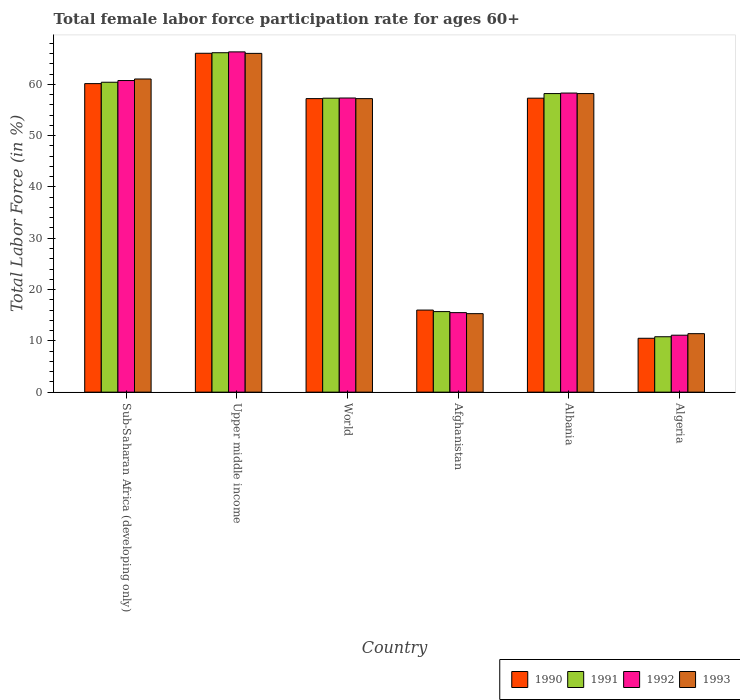How many groups of bars are there?
Provide a short and direct response. 6. What is the label of the 4th group of bars from the left?
Give a very brief answer. Afghanistan. What is the female labor force participation rate in 1991 in Afghanistan?
Keep it short and to the point. 15.7. Across all countries, what is the maximum female labor force participation rate in 1992?
Ensure brevity in your answer.  66.32. Across all countries, what is the minimum female labor force participation rate in 1991?
Offer a very short reply. 10.8. In which country was the female labor force participation rate in 1993 maximum?
Keep it short and to the point. Upper middle income. In which country was the female labor force participation rate in 1993 minimum?
Keep it short and to the point. Algeria. What is the total female labor force participation rate in 1992 in the graph?
Offer a very short reply. 269.3. What is the difference between the female labor force participation rate in 1990 in Algeria and that in World?
Provide a succinct answer. -46.71. What is the difference between the female labor force participation rate in 1991 in World and the female labor force participation rate in 1992 in Albania?
Provide a short and direct response. -1. What is the average female labor force participation rate in 1993 per country?
Your answer should be compact. 44.86. What is the difference between the female labor force participation rate of/in 1993 and female labor force participation rate of/in 1992 in Upper middle income?
Your answer should be very brief. -0.29. What is the ratio of the female labor force participation rate in 1990 in Albania to that in Upper middle income?
Offer a terse response. 0.87. What is the difference between the highest and the second highest female labor force participation rate in 1990?
Offer a terse response. -8.75. What is the difference between the highest and the lowest female labor force participation rate in 1993?
Provide a succinct answer. 54.63. Is the sum of the female labor force participation rate in 1991 in Albania and Algeria greater than the maximum female labor force participation rate in 1990 across all countries?
Offer a terse response. Yes. Is it the case that in every country, the sum of the female labor force participation rate in 1990 and female labor force participation rate in 1993 is greater than the sum of female labor force participation rate in 1992 and female labor force participation rate in 1991?
Offer a terse response. No. What does the 1st bar from the left in Sub-Saharan Africa (developing only) represents?
Your answer should be very brief. 1990. What does the 3rd bar from the right in World represents?
Your answer should be compact. 1991. Is it the case that in every country, the sum of the female labor force participation rate in 1993 and female labor force participation rate in 1991 is greater than the female labor force participation rate in 1990?
Your answer should be compact. Yes. Are all the bars in the graph horizontal?
Your answer should be very brief. No. How many countries are there in the graph?
Offer a very short reply. 6. What is the difference between two consecutive major ticks on the Y-axis?
Offer a terse response. 10. Are the values on the major ticks of Y-axis written in scientific E-notation?
Your answer should be very brief. No. Does the graph contain any zero values?
Make the answer very short. No. How many legend labels are there?
Ensure brevity in your answer.  4. What is the title of the graph?
Offer a terse response. Total female labor force participation rate for ages 60+. Does "2010" appear as one of the legend labels in the graph?
Your response must be concise. No. What is the label or title of the Y-axis?
Your answer should be very brief. Total Labor Force (in %). What is the Total Labor Force (in %) in 1990 in Sub-Saharan Africa (developing only)?
Offer a very short reply. 60.14. What is the Total Labor Force (in %) of 1991 in Sub-Saharan Africa (developing only)?
Provide a succinct answer. 60.41. What is the Total Labor Force (in %) in 1992 in Sub-Saharan Africa (developing only)?
Provide a succinct answer. 60.74. What is the Total Labor Force (in %) of 1993 in Sub-Saharan Africa (developing only)?
Ensure brevity in your answer.  61.04. What is the Total Labor Force (in %) of 1990 in Upper middle income?
Give a very brief answer. 66.05. What is the Total Labor Force (in %) of 1991 in Upper middle income?
Give a very brief answer. 66.16. What is the Total Labor Force (in %) of 1992 in Upper middle income?
Provide a short and direct response. 66.32. What is the Total Labor Force (in %) of 1993 in Upper middle income?
Ensure brevity in your answer.  66.03. What is the Total Labor Force (in %) in 1990 in World?
Keep it short and to the point. 57.21. What is the Total Labor Force (in %) of 1991 in World?
Offer a terse response. 57.3. What is the Total Labor Force (in %) in 1992 in World?
Keep it short and to the point. 57.33. What is the Total Labor Force (in %) in 1993 in World?
Your answer should be very brief. 57.21. What is the Total Labor Force (in %) in 1991 in Afghanistan?
Your response must be concise. 15.7. What is the Total Labor Force (in %) of 1993 in Afghanistan?
Offer a terse response. 15.3. What is the Total Labor Force (in %) in 1990 in Albania?
Give a very brief answer. 57.3. What is the Total Labor Force (in %) in 1991 in Albania?
Offer a terse response. 58.2. What is the Total Labor Force (in %) in 1992 in Albania?
Provide a short and direct response. 58.3. What is the Total Labor Force (in %) of 1993 in Albania?
Your answer should be compact. 58.2. What is the Total Labor Force (in %) in 1991 in Algeria?
Your answer should be compact. 10.8. What is the Total Labor Force (in %) in 1992 in Algeria?
Your answer should be very brief. 11.1. What is the Total Labor Force (in %) in 1993 in Algeria?
Offer a terse response. 11.4. Across all countries, what is the maximum Total Labor Force (in %) of 1990?
Your response must be concise. 66.05. Across all countries, what is the maximum Total Labor Force (in %) in 1991?
Offer a very short reply. 66.16. Across all countries, what is the maximum Total Labor Force (in %) of 1992?
Keep it short and to the point. 66.32. Across all countries, what is the maximum Total Labor Force (in %) of 1993?
Offer a very short reply. 66.03. Across all countries, what is the minimum Total Labor Force (in %) in 1990?
Offer a terse response. 10.5. Across all countries, what is the minimum Total Labor Force (in %) in 1991?
Provide a short and direct response. 10.8. Across all countries, what is the minimum Total Labor Force (in %) in 1992?
Provide a succinct answer. 11.1. Across all countries, what is the minimum Total Labor Force (in %) of 1993?
Keep it short and to the point. 11.4. What is the total Total Labor Force (in %) in 1990 in the graph?
Your answer should be very brief. 267.21. What is the total Total Labor Force (in %) of 1991 in the graph?
Make the answer very short. 268.57. What is the total Total Labor Force (in %) in 1992 in the graph?
Offer a very short reply. 269.3. What is the total Total Labor Force (in %) of 1993 in the graph?
Your answer should be compact. 269.18. What is the difference between the Total Labor Force (in %) of 1990 in Sub-Saharan Africa (developing only) and that in Upper middle income?
Keep it short and to the point. -5.92. What is the difference between the Total Labor Force (in %) in 1991 in Sub-Saharan Africa (developing only) and that in Upper middle income?
Keep it short and to the point. -5.75. What is the difference between the Total Labor Force (in %) in 1992 in Sub-Saharan Africa (developing only) and that in Upper middle income?
Your response must be concise. -5.58. What is the difference between the Total Labor Force (in %) of 1993 in Sub-Saharan Africa (developing only) and that in Upper middle income?
Give a very brief answer. -4.99. What is the difference between the Total Labor Force (in %) of 1990 in Sub-Saharan Africa (developing only) and that in World?
Your answer should be compact. 2.92. What is the difference between the Total Labor Force (in %) in 1991 in Sub-Saharan Africa (developing only) and that in World?
Your response must be concise. 3.11. What is the difference between the Total Labor Force (in %) of 1992 in Sub-Saharan Africa (developing only) and that in World?
Keep it short and to the point. 3.41. What is the difference between the Total Labor Force (in %) in 1993 in Sub-Saharan Africa (developing only) and that in World?
Make the answer very short. 3.83. What is the difference between the Total Labor Force (in %) in 1990 in Sub-Saharan Africa (developing only) and that in Afghanistan?
Ensure brevity in your answer.  44.14. What is the difference between the Total Labor Force (in %) in 1991 in Sub-Saharan Africa (developing only) and that in Afghanistan?
Provide a succinct answer. 44.71. What is the difference between the Total Labor Force (in %) of 1992 in Sub-Saharan Africa (developing only) and that in Afghanistan?
Give a very brief answer. 45.24. What is the difference between the Total Labor Force (in %) in 1993 in Sub-Saharan Africa (developing only) and that in Afghanistan?
Provide a succinct answer. 45.74. What is the difference between the Total Labor Force (in %) in 1990 in Sub-Saharan Africa (developing only) and that in Albania?
Your answer should be very brief. 2.84. What is the difference between the Total Labor Force (in %) in 1991 in Sub-Saharan Africa (developing only) and that in Albania?
Your answer should be very brief. 2.21. What is the difference between the Total Labor Force (in %) of 1992 in Sub-Saharan Africa (developing only) and that in Albania?
Your answer should be very brief. 2.44. What is the difference between the Total Labor Force (in %) in 1993 in Sub-Saharan Africa (developing only) and that in Albania?
Ensure brevity in your answer.  2.84. What is the difference between the Total Labor Force (in %) of 1990 in Sub-Saharan Africa (developing only) and that in Algeria?
Offer a terse response. 49.64. What is the difference between the Total Labor Force (in %) of 1991 in Sub-Saharan Africa (developing only) and that in Algeria?
Your answer should be compact. 49.61. What is the difference between the Total Labor Force (in %) of 1992 in Sub-Saharan Africa (developing only) and that in Algeria?
Keep it short and to the point. 49.64. What is the difference between the Total Labor Force (in %) in 1993 in Sub-Saharan Africa (developing only) and that in Algeria?
Make the answer very short. 49.64. What is the difference between the Total Labor Force (in %) in 1990 in Upper middle income and that in World?
Keep it short and to the point. 8.84. What is the difference between the Total Labor Force (in %) in 1991 in Upper middle income and that in World?
Ensure brevity in your answer.  8.86. What is the difference between the Total Labor Force (in %) in 1992 in Upper middle income and that in World?
Make the answer very short. 8.99. What is the difference between the Total Labor Force (in %) of 1993 in Upper middle income and that in World?
Your answer should be compact. 8.82. What is the difference between the Total Labor Force (in %) in 1990 in Upper middle income and that in Afghanistan?
Ensure brevity in your answer.  50.05. What is the difference between the Total Labor Force (in %) of 1991 in Upper middle income and that in Afghanistan?
Give a very brief answer. 50.46. What is the difference between the Total Labor Force (in %) of 1992 in Upper middle income and that in Afghanistan?
Ensure brevity in your answer.  50.82. What is the difference between the Total Labor Force (in %) in 1993 in Upper middle income and that in Afghanistan?
Offer a very short reply. 50.73. What is the difference between the Total Labor Force (in %) in 1990 in Upper middle income and that in Albania?
Make the answer very short. 8.75. What is the difference between the Total Labor Force (in %) of 1991 in Upper middle income and that in Albania?
Your answer should be compact. 7.96. What is the difference between the Total Labor Force (in %) in 1992 in Upper middle income and that in Albania?
Give a very brief answer. 8.02. What is the difference between the Total Labor Force (in %) of 1993 in Upper middle income and that in Albania?
Keep it short and to the point. 7.83. What is the difference between the Total Labor Force (in %) in 1990 in Upper middle income and that in Algeria?
Provide a succinct answer. 55.55. What is the difference between the Total Labor Force (in %) of 1991 in Upper middle income and that in Algeria?
Provide a short and direct response. 55.36. What is the difference between the Total Labor Force (in %) in 1992 in Upper middle income and that in Algeria?
Keep it short and to the point. 55.22. What is the difference between the Total Labor Force (in %) of 1993 in Upper middle income and that in Algeria?
Give a very brief answer. 54.63. What is the difference between the Total Labor Force (in %) in 1990 in World and that in Afghanistan?
Offer a terse response. 41.21. What is the difference between the Total Labor Force (in %) in 1991 in World and that in Afghanistan?
Provide a succinct answer. 41.6. What is the difference between the Total Labor Force (in %) in 1992 in World and that in Afghanistan?
Provide a short and direct response. 41.83. What is the difference between the Total Labor Force (in %) of 1993 in World and that in Afghanistan?
Your answer should be very brief. 41.91. What is the difference between the Total Labor Force (in %) of 1990 in World and that in Albania?
Give a very brief answer. -0.09. What is the difference between the Total Labor Force (in %) of 1991 in World and that in Albania?
Provide a succinct answer. -0.9. What is the difference between the Total Labor Force (in %) in 1992 in World and that in Albania?
Ensure brevity in your answer.  -0.97. What is the difference between the Total Labor Force (in %) of 1993 in World and that in Albania?
Your response must be concise. -0.99. What is the difference between the Total Labor Force (in %) of 1990 in World and that in Algeria?
Provide a short and direct response. 46.71. What is the difference between the Total Labor Force (in %) in 1991 in World and that in Algeria?
Provide a short and direct response. 46.5. What is the difference between the Total Labor Force (in %) of 1992 in World and that in Algeria?
Offer a very short reply. 46.23. What is the difference between the Total Labor Force (in %) of 1993 in World and that in Algeria?
Your response must be concise. 45.81. What is the difference between the Total Labor Force (in %) of 1990 in Afghanistan and that in Albania?
Offer a terse response. -41.3. What is the difference between the Total Labor Force (in %) in 1991 in Afghanistan and that in Albania?
Provide a succinct answer. -42.5. What is the difference between the Total Labor Force (in %) of 1992 in Afghanistan and that in Albania?
Give a very brief answer. -42.8. What is the difference between the Total Labor Force (in %) in 1993 in Afghanistan and that in Albania?
Offer a very short reply. -42.9. What is the difference between the Total Labor Force (in %) of 1990 in Afghanistan and that in Algeria?
Make the answer very short. 5.5. What is the difference between the Total Labor Force (in %) in 1991 in Afghanistan and that in Algeria?
Offer a terse response. 4.9. What is the difference between the Total Labor Force (in %) of 1990 in Albania and that in Algeria?
Offer a very short reply. 46.8. What is the difference between the Total Labor Force (in %) of 1991 in Albania and that in Algeria?
Make the answer very short. 47.4. What is the difference between the Total Labor Force (in %) of 1992 in Albania and that in Algeria?
Keep it short and to the point. 47.2. What is the difference between the Total Labor Force (in %) in 1993 in Albania and that in Algeria?
Make the answer very short. 46.8. What is the difference between the Total Labor Force (in %) of 1990 in Sub-Saharan Africa (developing only) and the Total Labor Force (in %) of 1991 in Upper middle income?
Your response must be concise. -6.02. What is the difference between the Total Labor Force (in %) in 1990 in Sub-Saharan Africa (developing only) and the Total Labor Force (in %) in 1992 in Upper middle income?
Your response must be concise. -6.18. What is the difference between the Total Labor Force (in %) in 1990 in Sub-Saharan Africa (developing only) and the Total Labor Force (in %) in 1993 in Upper middle income?
Offer a very short reply. -5.89. What is the difference between the Total Labor Force (in %) of 1991 in Sub-Saharan Africa (developing only) and the Total Labor Force (in %) of 1992 in Upper middle income?
Provide a succinct answer. -5.92. What is the difference between the Total Labor Force (in %) in 1991 in Sub-Saharan Africa (developing only) and the Total Labor Force (in %) in 1993 in Upper middle income?
Your answer should be very brief. -5.63. What is the difference between the Total Labor Force (in %) of 1992 in Sub-Saharan Africa (developing only) and the Total Labor Force (in %) of 1993 in Upper middle income?
Offer a very short reply. -5.29. What is the difference between the Total Labor Force (in %) of 1990 in Sub-Saharan Africa (developing only) and the Total Labor Force (in %) of 1991 in World?
Make the answer very short. 2.84. What is the difference between the Total Labor Force (in %) of 1990 in Sub-Saharan Africa (developing only) and the Total Labor Force (in %) of 1992 in World?
Ensure brevity in your answer.  2.81. What is the difference between the Total Labor Force (in %) in 1990 in Sub-Saharan Africa (developing only) and the Total Labor Force (in %) in 1993 in World?
Offer a very short reply. 2.93. What is the difference between the Total Labor Force (in %) of 1991 in Sub-Saharan Africa (developing only) and the Total Labor Force (in %) of 1992 in World?
Your response must be concise. 3.07. What is the difference between the Total Labor Force (in %) in 1991 in Sub-Saharan Africa (developing only) and the Total Labor Force (in %) in 1993 in World?
Provide a short and direct response. 3.2. What is the difference between the Total Labor Force (in %) of 1992 in Sub-Saharan Africa (developing only) and the Total Labor Force (in %) of 1993 in World?
Your response must be concise. 3.53. What is the difference between the Total Labor Force (in %) of 1990 in Sub-Saharan Africa (developing only) and the Total Labor Force (in %) of 1991 in Afghanistan?
Offer a very short reply. 44.44. What is the difference between the Total Labor Force (in %) in 1990 in Sub-Saharan Africa (developing only) and the Total Labor Force (in %) in 1992 in Afghanistan?
Ensure brevity in your answer.  44.64. What is the difference between the Total Labor Force (in %) of 1990 in Sub-Saharan Africa (developing only) and the Total Labor Force (in %) of 1993 in Afghanistan?
Provide a short and direct response. 44.84. What is the difference between the Total Labor Force (in %) of 1991 in Sub-Saharan Africa (developing only) and the Total Labor Force (in %) of 1992 in Afghanistan?
Offer a terse response. 44.91. What is the difference between the Total Labor Force (in %) of 1991 in Sub-Saharan Africa (developing only) and the Total Labor Force (in %) of 1993 in Afghanistan?
Ensure brevity in your answer.  45.11. What is the difference between the Total Labor Force (in %) in 1992 in Sub-Saharan Africa (developing only) and the Total Labor Force (in %) in 1993 in Afghanistan?
Ensure brevity in your answer.  45.44. What is the difference between the Total Labor Force (in %) in 1990 in Sub-Saharan Africa (developing only) and the Total Labor Force (in %) in 1991 in Albania?
Offer a terse response. 1.94. What is the difference between the Total Labor Force (in %) in 1990 in Sub-Saharan Africa (developing only) and the Total Labor Force (in %) in 1992 in Albania?
Make the answer very short. 1.84. What is the difference between the Total Labor Force (in %) of 1990 in Sub-Saharan Africa (developing only) and the Total Labor Force (in %) of 1993 in Albania?
Your answer should be compact. 1.94. What is the difference between the Total Labor Force (in %) in 1991 in Sub-Saharan Africa (developing only) and the Total Labor Force (in %) in 1992 in Albania?
Provide a succinct answer. 2.11. What is the difference between the Total Labor Force (in %) of 1991 in Sub-Saharan Africa (developing only) and the Total Labor Force (in %) of 1993 in Albania?
Ensure brevity in your answer.  2.21. What is the difference between the Total Labor Force (in %) of 1992 in Sub-Saharan Africa (developing only) and the Total Labor Force (in %) of 1993 in Albania?
Provide a succinct answer. 2.54. What is the difference between the Total Labor Force (in %) in 1990 in Sub-Saharan Africa (developing only) and the Total Labor Force (in %) in 1991 in Algeria?
Make the answer very short. 49.34. What is the difference between the Total Labor Force (in %) of 1990 in Sub-Saharan Africa (developing only) and the Total Labor Force (in %) of 1992 in Algeria?
Your answer should be very brief. 49.04. What is the difference between the Total Labor Force (in %) of 1990 in Sub-Saharan Africa (developing only) and the Total Labor Force (in %) of 1993 in Algeria?
Your answer should be compact. 48.74. What is the difference between the Total Labor Force (in %) in 1991 in Sub-Saharan Africa (developing only) and the Total Labor Force (in %) in 1992 in Algeria?
Your response must be concise. 49.31. What is the difference between the Total Labor Force (in %) in 1991 in Sub-Saharan Africa (developing only) and the Total Labor Force (in %) in 1993 in Algeria?
Offer a very short reply. 49.01. What is the difference between the Total Labor Force (in %) of 1992 in Sub-Saharan Africa (developing only) and the Total Labor Force (in %) of 1993 in Algeria?
Your answer should be compact. 49.34. What is the difference between the Total Labor Force (in %) in 1990 in Upper middle income and the Total Labor Force (in %) in 1991 in World?
Offer a terse response. 8.75. What is the difference between the Total Labor Force (in %) of 1990 in Upper middle income and the Total Labor Force (in %) of 1992 in World?
Offer a terse response. 8.72. What is the difference between the Total Labor Force (in %) in 1990 in Upper middle income and the Total Labor Force (in %) in 1993 in World?
Give a very brief answer. 8.84. What is the difference between the Total Labor Force (in %) in 1991 in Upper middle income and the Total Labor Force (in %) in 1992 in World?
Your answer should be compact. 8.83. What is the difference between the Total Labor Force (in %) in 1991 in Upper middle income and the Total Labor Force (in %) in 1993 in World?
Provide a short and direct response. 8.95. What is the difference between the Total Labor Force (in %) of 1992 in Upper middle income and the Total Labor Force (in %) of 1993 in World?
Your answer should be very brief. 9.11. What is the difference between the Total Labor Force (in %) of 1990 in Upper middle income and the Total Labor Force (in %) of 1991 in Afghanistan?
Offer a very short reply. 50.35. What is the difference between the Total Labor Force (in %) in 1990 in Upper middle income and the Total Labor Force (in %) in 1992 in Afghanistan?
Your answer should be compact. 50.55. What is the difference between the Total Labor Force (in %) of 1990 in Upper middle income and the Total Labor Force (in %) of 1993 in Afghanistan?
Offer a very short reply. 50.75. What is the difference between the Total Labor Force (in %) of 1991 in Upper middle income and the Total Labor Force (in %) of 1992 in Afghanistan?
Give a very brief answer. 50.66. What is the difference between the Total Labor Force (in %) in 1991 in Upper middle income and the Total Labor Force (in %) in 1993 in Afghanistan?
Offer a very short reply. 50.86. What is the difference between the Total Labor Force (in %) in 1992 in Upper middle income and the Total Labor Force (in %) in 1993 in Afghanistan?
Give a very brief answer. 51.02. What is the difference between the Total Labor Force (in %) of 1990 in Upper middle income and the Total Labor Force (in %) of 1991 in Albania?
Your answer should be very brief. 7.85. What is the difference between the Total Labor Force (in %) in 1990 in Upper middle income and the Total Labor Force (in %) in 1992 in Albania?
Your answer should be compact. 7.75. What is the difference between the Total Labor Force (in %) of 1990 in Upper middle income and the Total Labor Force (in %) of 1993 in Albania?
Keep it short and to the point. 7.85. What is the difference between the Total Labor Force (in %) in 1991 in Upper middle income and the Total Labor Force (in %) in 1992 in Albania?
Ensure brevity in your answer.  7.86. What is the difference between the Total Labor Force (in %) in 1991 in Upper middle income and the Total Labor Force (in %) in 1993 in Albania?
Provide a succinct answer. 7.96. What is the difference between the Total Labor Force (in %) of 1992 in Upper middle income and the Total Labor Force (in %) of 1993 in Albania?
Offer a terse response. 8.12. What is the difference between the Total Labor Force (in %) in 1990 in Upper middle income and the Total Labor Force (in %) in 1991 in Algeria?
Your response must be concise. 55.25. What is the difference between the Total Labor Force (in %) in 1990 in Upper middle income and the Total Labor Force (in %) in 1992 in Algeria?
Provide a short and direct response. 54.95. What is the difference between the Total Labor Force (in %) of 1990 in Upper middle income and the Total Labor Force (in %) of 1993 in Algeria?
Provide a succinct answer. 54.65. What is the difference between the Total Labor Force (in %) in 1991 in Upper middle income and the Total Labor Force (in %) in 1992 in Algeria?
Ensure brevity in your answer.  55.06. What is the difference between the Total Labor Force (in %) of 1991 in Upper middle income and the Total Labor Force (in %) of 1993 in Algeria?
Your answer should be very brief. 54.76. What is the difference between the Total Labor Force (in %) of 1992 in Upper middle income and the Total Labor Force (in %) of 1993 in Algeria?
Offer a terse response. 54.92. What is the difference between the Total Labor Force (in %) of 1990 in World and the Total Labor Force (in %) of 1991 in Afghanistan?
Provide a short and direct response. 41.51. What is the difference between the Total Labor Force (in %) of 1990 in World and the Total Labor Force (in %) of 1992 in Afghanistan?
Ensure brevity in your answer.  41.71. What is the difference between the Total Labor Force (in %) in 1990 in World and the Total Labor Force (in %) in 1993 in Afghanistan?
Your answer should be very brief. 41.91. What is the difference between the Total Labor Force (in %) in 1991 in World and the Total Labor Force (in %) in 1992 in Afghanistan?
Your response must be concise. 41.8. What is the difference between the Total Labor Force (in %) in 1991 in World and the Total Labor Force (in %) in 1993 in Afghanistan?
Your response must be concise. 42. What is the difference between the Total Labor Force (in %) in 1992 in World and the Total Labor Force (in %) in 1993 in Afghanistan?
Make the answer very short. 42.03. What is the difference between the Total Labor Force (in %) of 1990 in World and the Total Labor Force (in %) of 1991 in Albania?
Ensure brevity in your answer.  -0.99. What is the difference between the Total Labor Force (in %) of 1990 in World and the Total Labor Force (in %) of 1992 in Albania?
Keep it short and to the point. -1.09. What is the difference between the Total Labor Force (in %) in 1990 in World and the Total Labor Force (in %) in 1993 in Albania?
Ensure brevity in your answer.  -0.99. What is the difference between the Total Labor Force (in %) of 1991 in World and the Total Labor Force (in %) of 1992 in Albania?
Your answer should be very brief. -1. What is the difference between the Total Labor Force (in %) of 1991 in World and the Total Labor Force (in %) of 1993 in Albania?
Ensure brevity in your answer.  -0.9. What is the difference between the Total Labor Force (in %) of 1992 in World and the Total Labor Force (in %) of 1993 in Albania?
Offer a terse response. -0.87. What is the difference between the Total Labor Force (in %) of 1990 in World and the Total Labor Force (in %) of 1991 in Algeria?
Your answer should be compact. 46.41. What is the difference between the Total Labor Force (in %) in 1990 in World and the Total Labor Force (in %) in 1992 in Algeria?
Ensure brevity in your answer.  46.11. What is the difference between the Total Labor Force (in %) of 1990 in World and the Total Labor Force (in %) of 1993 in Algeria?
Provide a short and direct response. 45.81. What is the difference between the Total Labor Force (in %) of 1991 in World and the Total Labor Force (in %) of 1992 in Algeria?
Make the answer very short. 46.2. What is the difference between the Total Labor Force (in %) in 1991 in World and the Total Labor Force (in %) in 1993 in Algeria?
Your response must be concise. 45.9. What is the difference between the Total Labor Force (in %) in 1992 in World and the Total Labor Force (in %) in 1993 in Algeria?
Offer a terse response. 45.93. What is the difference between the Total Labor Force (in %) in 1990 in Afghanistan and the Total Labor Force (in %) in 1991 in Albania?
Keep it short and to the point. -42.2. What is the difference between the Total Labor Force (in %) of 1990 in Afghanistan and the Total Labor Force (in %) of 1992 in Albania?
Provide a succinct answer. -42.3. What is the difference between the Total Labor Force (in %) of 1990 in Afghanistan and the Total Labor Force (in %) of 1993 in Albania?
Ensure brevity in your answer.  -42.2. What is the difference between the Total Labor Force (in %) in 1991 in Afghanistan and the Total Labor Force (in %) in 1992 in Albania?
Make the answer very short. -42.6. What is the difference between the Total Labor Force (in %) in 1991 in Afghanistan and the Total Labor Force (in %) in 1993 in Albania?
Ensure brevity in your answer.  -42.5. What is the difference between the Total Labor Force (in %) in 1992 in Afghanistan and the Total Labor Force (in %) in 1993 in Albania?
Make the answer very short. -42.7. What is the difference between the Total Labor Force (in %) in 1990 in Afghanistan and the Total Labor Force (in %) in 1992 in Algeria?
Keep it short and to the point. 4.9. What is the difference between the Total Labor Force (in %) of 1991 in Afghanistan and the Total Labor Force (in %) of 1992 in Algeria?
Provide a short and direct response. 4.6. What is the difference between the Total Labor Force (in %) in 1991 in Afghanistan and the Total Labor Force (in %) in 1993 in Algeria?
Provide a short and direct response. 4.3. What is the difference between the Total Labor Force (in %) of 1990 in Albania and the Total Labor Force (in %) of 1991 in Algeria?
Provide a short and direct response. 46.5. What is the difference between the Total Labor Force (in %) in 1990 in Albania and the Total Labor Force (in %) in 1992 in Algeria?
Ensure brevity in your answer.  46.2. What is the difference between the Total Labor Force (in %) in 1990 in Albania and the Total Labor Force (in %) in 1993 in Algeria?
Your answer should be very brief. 45.9. What is the difference between the Total Labor Force (in %) of 1991 in Albania and the Total Labor Force (in %) of 1992 in Algeria?
Make the answer very short. 47.1. What is the difference between the Total Labor Force (in %) of 1991 in Albania and the Total Labor Force (in %) of 1993 in Algeria?
Give a very brief answer. 46.8. What is the difference between the Total Labor Force (in %) of 1992 in Albania and the Total Labor Force (in %) of 1993 in Algeria?
Your answer should be compact. 46.9. What is the average Total Labor Force (in %) of 1990 per country?
Offer a terse response. 44.53. What is the average Total Labor Force (in %) of 1991 per country?
Offer a terse response. 44.76. What is the average Total Labor Force (in %) of 1992 per country?
Keep it short and to the point. 44.88. What is the average Total Labor Force (in %) in 1993 per country?
Ensure brevity in your answer.  44.86. What is the difference between the Total Labor Force (in %) of 1990 and Total Labor Force (in %) of 1991 in Sub-Saharan Africa (developing only)?
Give a very brief answer. -0.27. What is the difference between the Total Labor Force (in %) of 1990 and Total Labor Force (in %) of 1992 in Sub-Saharan Africa (developing only)?
Your response must be concise. -0.6. What is the difference between the Total Labor Force (in %) in 1990 and Total Labor Force (in %) in 1993 in Sub-Saharan Africa (developing only)?
Keep it short and to the point. -0.9. What is the difference between the Total Labor Force (in %) in 1991 and Total Labor Force (in %) in 1992 in Sub-Saharan Africa (developing only)?
Offer a terse response. -0.33. What is the difference between the Total Labor Force (in %) of 1991 and Total Labor Force (in %) of 1993 in Sub-Saharan Africa (developing only)?
Provide a succinct answer. -0.63. What is the difference between the Total Labor Force (in %) in 1990 and Total Labor Force (in %) in 1991 in Upper middle income?
Keep it short and to the point. -0.11. What is the difference between the Total Labor Force (in %) in 1990 and Total Labor Force (in %) in 1992 in Upper middle income?
Ensure brevity in your answer.  -0.27. What is the difference between the Total Labor Force (in %) of 1990 and Total Labor Force (in %) of 1993 in Upper middle income?
Your answer should be compact. 0.02. What is the difference between the Total Labor Force (in %) of 1991 and Total Labor Force (in %) of 1992 in Upper middle income?
Offer a very short reply. -0.16. What is the difference between the Total Labor Force (in %) in 1991 and Total Labor Force (in %) in 1993 in Upper middle income?
Ensure brevity in your answer.  0.13. What is the difference between the Total Labor Force (in %) in 1992 and Total Labor Force (in %) in 1993 in Upper middle income?
Offer a very short reply. 0.29. What is the difference between the Total Labor Force (in %) in 1990 and Total Labor Force (in %) in 1991 in World?
Keep it short and to the point. -0.09. What is the difference between the Total Labor Force (in %) of 1990 and Total Labor Force (in %) of 1992 in World?
Your answer should be very brief. -0.12. What is the difference between the Total Labor Force (in %) in 1990 and Total Labor Force (in %) in 1993 in World?
Your answer should be compact. 0. What is the difference between the Total Labor Force (in %) of 1991 and Total Labor Force (in %) of 1992 in World?
Ensure brevity in your answer.  -0.03. What is the difference between the Total Labor Force (in %) in 1991 and Total Labor Force (in %) in 1993 in World?
Make the answer very short. 0.09. What is the difference between the Total Labor Force (in %) in 1992 and Total Labor Force (in %) in 1993 in World?
Offer a terse response. 0.12. What is the difference between the Total Labor Force (in %) of 1992 and Total Labor Force (in %) of 1993 in Afghanistan?
Your answer should be compact. 0.2. What is the difference between the Total Labor Force (in %) in 1990 and Total Labor Force (in %) in 1991 in Albania?
Keep it short and to the point. -0.9. What is the difference between the Total Labor Force (in %) of 1991 and Total Labor Force (in %) of 1992 in Albania?
Your answer should be very brief. -0.1. What is the difference between the Total Labor Force (in %) in 1991 and Total Labor Force (in %) in 1993 in Albania?
Your answer should be compact. 0. What is the difference between the Total Labor Force (in %) of 1990 and Total Labor Force (in %) of 1992 in Algeria?
Offer a terse response. -0.6. What is the difference between the Total Labor Force (in %) of 1990 and Total Labor Force (in %) of 1993 in Algeria?
Provide a succinct answer. -0.9. What is the difference between the Total Labor Force (in %) of 1991 and Total Labor Force (in %) of 1992 in Algeria?
Your answer should be compact. -0.3. What is the ratio of the Total Labor Force (in %) in 1990 in Sub-Saharan Africa (developing only) to that in Upper middle income?
Your response must be concise. 0.91. What is the ratio of the Total Labor Force (in %) of 1992 in Sub-Saharan Africa (developing only) to that in Upper middle income?
Provide a short and direct response. 0.92. What is the ratio of the Total Labor Force (in %) in 1993 in Sub-Saharan Africa (developing only) to that in Upper middle income?
Offer a terse response. 0.92. What is the ratio of the Total Labor Force (in %) of 1990 in Sub-Saharan Africa (developing only) to that in World?
Ensure brevity in your answer.  1.05. What is the ratio of the Total Labor Force (in %) in 1991 in Sub-Saharan Africa (developing only) to that in World?
Ensure brevity in your answer.  1.05. What is the ratio of the Total Labor Force (in %) in 1992 in Sub-Saharan Africa (developing only) to that in World?
Your answer should be very brief. 1.06. What is the ratio of the Total Labor Force (in %) of 1993 in Sub-Saharan Africa (developing only) to that in World?
Your answer should be very brief. 1.07. What is the ratio of the Total Labor Force (in %) of 1990 in Sub-Saharan Africa (developing only) to that in Afghanistan?
Keep it short and to the point. 3.76. What is the ratio of the Total Labor Force (in %) of 1991 in Sub-Saharan Africa (developing only) to that in Afghanistan?
Ensure brevity in your answer.  3.85. What is the ratio of the Total Labor Force (in %) of 1992 in Sub-Saharan Africa (developing only) to that in Afghanistan?
Provide a short and direct response. 3.92. What is the ratio of the Total Labor Force (in %) in 1993 in Sub-Saharan Africa (developing only) to that in Afghanistan?
Provide a short and direct response. 3.99. What is the ratio of the Total Labor Force (in %) of 1990 in Sub-Saharan Africa (developing only) to that in Albania?
Give a very brief answer. 1.05. What is the ratio of the Total Labor Force (in %) in 1991 in Sub-Saharan Africa (developing only) to that in Albania?
Make the answer very short. 1.04. What is the ratio of the Total Labor Force (in %) of 1992 in Sub-Saharan Africa (developing only) to that in Albania?
Give a very brief answer. 1.04. What is the ratio of the Total Labor Force (in %) in 1993 in Sub-Saharan Africa (developing only) to that in Albania?
Make the answer very short. 1.05. What is the ratio of the Total Labor Force (in %) of 1990 in Sub-Saharan Africa (developing only) to that in Algeria?
Offer a very short reply. 5.73. What is the ratio of the Total Labor Force (in %) of 1991 in Sub-Saharan Africa (developing only) to that in Algeria?
Keep it short and to the point. 5.59. What is the ratio of the Total Labor Force (in %) in 1992 in Sub-Saharan Africa (developing only) to that in Algeria?
Keep it short and to the point. 5.47. What is the ratio of the Total Labor Force (in %) of 1993 in Sub-Saharan Africa (developing only) to that in Algeria?
Your answer should be compact. 5.35. What is the ratio of the Total Labor Force (in %) of 1990 in Upper middle income to that in World?
Your answer should be compact. 1.15. What is the ratio of the Total Labor Force (in %) of 1991 in Upper middle income to that in World?
Offer a terse response. 1.15. What is the ratio of the Total Labor Force (in %) in 1992 in Upper middle income to that in World?
Provide a succinct answer. 1.16. What is the ratio of the Total Labor Force (in %) of 1993 in Upper middle income to that in World?
Offer a terse response. 1.15. What is the ratio of the Total Labor Force (in %) in 1990 in Upper middle income to that in Afghanistan?
Offer a terse response. 4.13. What is the ratio of the Total Labor Force (in %) in 1991 in Upper middle income to that in Afghanistan?
Make the answer very short. 4.21. What is the ratio of the Total Labor Force (in %) of 1992 in Upper middle income to that in Afghanistan?
Make the answer very short. 4.28. What is the ratio of the Total Labor Force (in %) in 1993 in Upper middle income to that in Afghanistan?
Provide a short and direct response. 4.32. What is the ratio of the Total Labor Force (in %) in 1990 in Upper middle income to that in Albania?
Keep it short and to the point. 1.15. What is the ratio of the Total Labor Force (in %) of 1991 in Upper middle income to that in Albania?
Provide a short and direct response. 1.14. What is the ratio of the Total Labor Force (in %) in 1992 in Upper middle income to that in Albania?
Offer a very short reply. 1.14. What is the ratio of the Total Labor Force (in %) of 1993 in Upper middle income to that in Albania?
Your answer should be compact. 1.13. What is the ratio of the Total Labor Force (in %) of 1990 in Upper middle income to that in Algeria?
Offer a very short reply. 6.29. What is the ratio of the Total Labor Force (in %) of 1991 in Upper middle income to that in Algeria?
Make the answer very short. 6.13. What is the ratio of the Total Labor Force (in %) of 1992 in Upper middle income to that in Algeria?
Ensure brevity in your answer.  5.98. What is the ratio of the Total Labor Force (in %) of 1993 in Upper middle income to that in Algeria?
Give a very brief answer. 5.79. What is the ratio of the Total Labor Force (in %) of 1990 in World to that in Afghanistan?
Keep it short and to the point. 3.58. What is the ratio of the Total Labor Force (in %) of 1991 in World to that in Afghanistan?
Keep it short and to the point. 3.65. What is the ratio of the Total Labor Force (in %) of 1992 in World to that in Afghanistan?
Your response must be concise. 3.7. What is the ratio of the Total Labor Force (in %) of 1993 in World to that in Afghanistan?
Offer a terse response. 3.74. What is the ratio of the Total Labor Force (in %) in 1990 in World to that in Albania?
Give a very brief answer. 1. What is the ratio of the Total Labor Force (in %) in 1991 in World to that in Albania?
Your response must be concise. 0.98. What is the ratio of the Total Labor Force (in %) in 1992 in World to that in Albania?
Offer a terse response. 0.98. What is the ratio of the Total Labor Force (in %) of 1993 in World to that in Albania?
Ensure brevity in your answer.  0.98. What is the ratio of the Total Labor Force (in %) of 1990 in World to that in Algeria?
Offer a terse response. 5.45. What is the ratio of the Total Labor Force (in %) in 1991 in World to that in Algeria?
Your answer should be very brief. 5.31. What is the ratio of the Total Labor Force (in %) of 1992 in World to that in Algeria?
Your response must be concise. 5.17. What is the ratio of the Total Labor Force (in %) in 1993 in World to that in Algeria?
Provide a succinct answer. 5.02. What is the ratio of the Total Labor Force (in %) in 1990 in Afghanistan to that in Albania?
Your answer should be compact. 0.28. What is the ratio of the Total Labor Force (in %) of 1991 in Afghanistan to that in Albania?
Make the answer very short. 0.27. What is the ratio of the Total Labor Force (in %) of 1992 in Afghanistan to that in Albania?
Your answer should be very brief. 0.27. What is the ratio of the Total Labor Force (in %) in 1993 in Afghanistan to that in Albania?
Offer a very short reply. 0.26. What is the ratio of the Total Labor Force (in %) in 1990 in Afghanistan to that in Algeria?
Your response must be concise. 1.52. What is the ratio of the Total Labor Force (in %) in 1991 in Afghanistan to that in Algeria?
Your answer should be compact. 1.45. What is the ratio of the Total Labor Force (in %) in 1992 in Afghanistan to that in Algeria?
Provide a short and direct response. 1.4. What is the ratio of the Total Labor Force (in %) in 1993 in Afghanistan to that in Algeria?
Provide a short and direct response. 1.34. What is the ratio of the Total Labor Force (in %) in 1990 in Albania to that in Algeria?
Make the answer very short. 5.46. What is the ratio of the Total Labor Force (in %) in 1991 in Albania to that in Algeria?
Offer a very short reply. 5.39. What is the ratio of the Total Labor Force (in %) of 1992 in Albania to that in Algeria?
Offer a terse response. 5.25. What is the ratio of the Total Labor Force (in %) in 1993 in Albania to that in Algeria?
Make the answer very short. 5.11. What is the difference between the highest and the second highest Total Labor Force (in %) in 1990?
Offer a very short reply. 5.92. What is the difference between the highest and the second highest Total Labor Force (in %) in 1991?
Keep it short and to the point. 5.75. What is the difference between the highest and the second highest Total Labor Force (in %) in 1992?
Offer a terse response. 5.58. What is the difference between the highest and the second highest Total Labor Force (in %) in 1993?
Your answer should be compact. 4.99. What is the difference between the highest and the lowest Total Labor Force (in %) in 1990?
Your response must be concise. 55.55. What is the difference between the highest and the lowest Total Labor Force (in %) in 1991?
Offer a terse response. 55.36. What is the difference between the highest and the lowest Total Labor Force (in %) of 1992?
Keep it short and to the point. 55.22. What is the difference between the highest and the lowest Total Labor Force (in %) of 1993?
Offer a terse response. 54.63. 